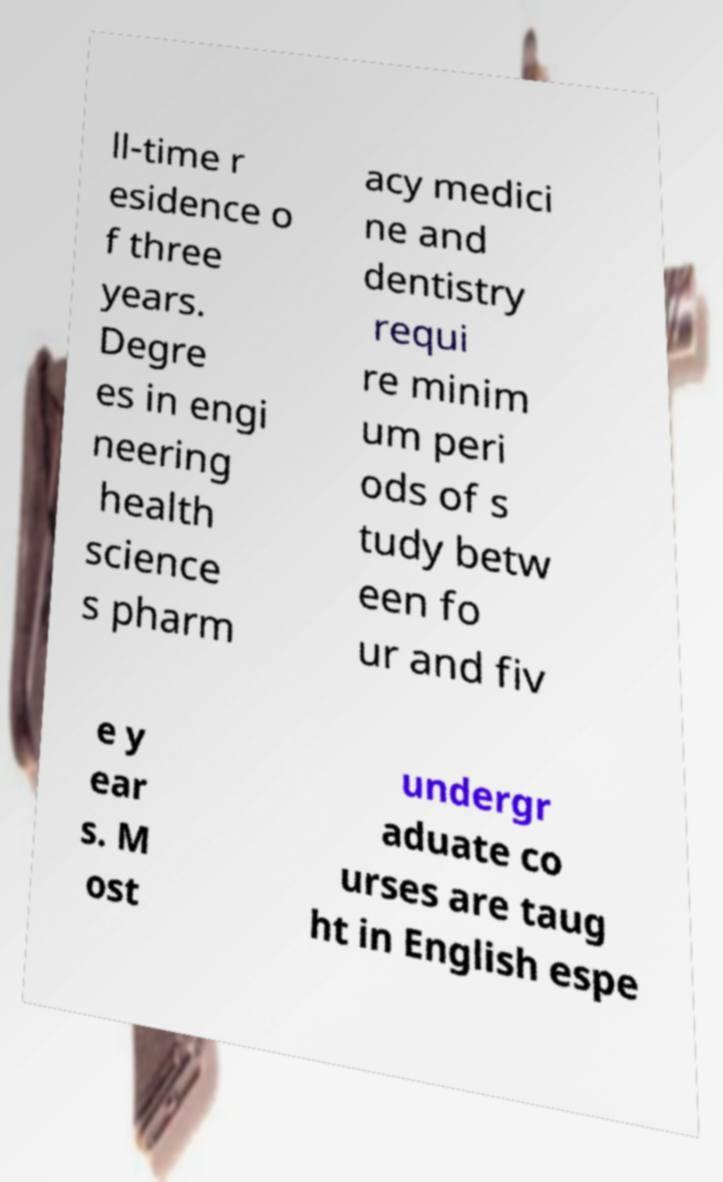Could you assist in decoding the text presented in this image and type it out clearly? ll-time r esidence o f three years. Degre es in engi neering health science s pharm acy medici ne and dentistry requi re minim um peri ods of s tudy betw een fo ur and fiv e y ear s. M ost undergr aduate co urses are taug ht in English espe 